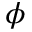Convert formula to latex. <formula><loc_0><loc_0><loc_500><loc_500>\phi</formula> 